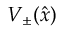<formula> <loc_0><loc_0><loc_500><loc_500>V _ { \pm } ( \hat { x } )</formula> 